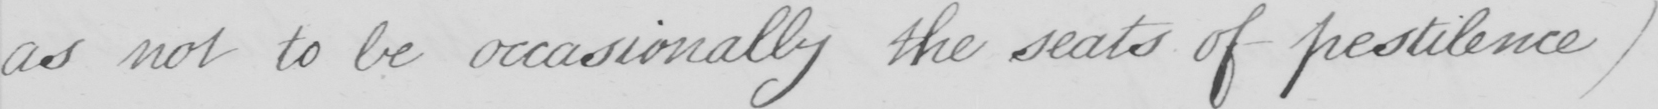What text is written in this handwritten line? as not to be occasionally the seats of pestilence ) 